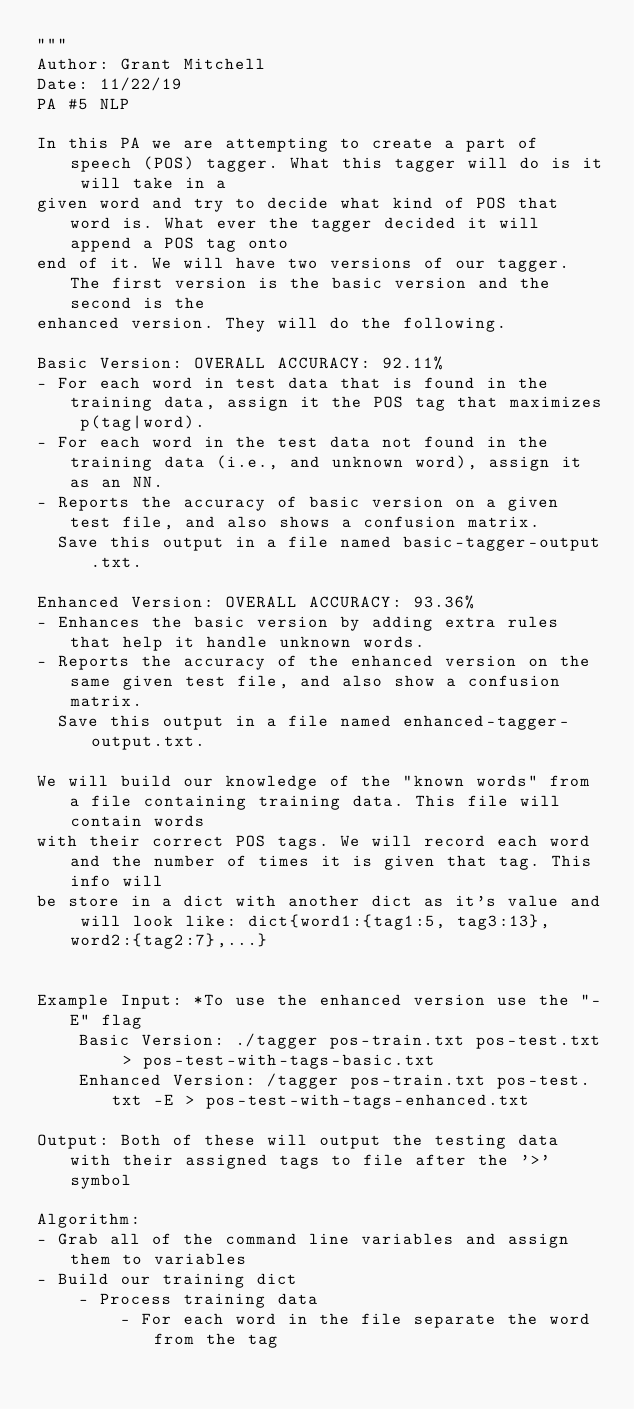Convert code to text. <code><loc_0><loc_0><loc_500><loc_500><_Python_>"""
Author: Grant Mitchell
Date: 11/22/19
PA #5 NLP

In this PA we are attempting to create a part of speech (POS) tagger. What this tagger will do is it will take in a
given word and try to decide what kind of POS that word is. What ever the tagger decided it will append a POS tag onto
end of it. We will have two versions of our tagger. The first version is the basic version and the second is the
enhanced version. They will do the following.

Basic Version: OVERALL ACCURACY: 92.11%
- For each word in test data that is found in the training data, assign it the POS tag that maximizes p(tag|word).
- For each word in the test data not found in the training data (i.e., and unknown word), assign it as an NN.
- Reports the accuracy of basic version on a given test file, and also shows a confusion matrix.
  Save this output in a file named basic-tagger-output.txt.

Enhanced Version: OVERALL ACCURACY: 93.36%
- Enhances the basic version by adding extra rules that help it handle unknown words.
- Reports the accuracy of the enhanced version on the same given test file, and also show a confusion matrix.
  Save this output in a file named enhanced-tagger-output.txt.

We will build our knowledge of the "known words" from a file containing training data. This file will contain words
with their correct POS tags. We will record each word and the number of times it is given that tag. This info will
be store in a dict with another dict as it's value and will look like: dict{word1:{tag1:5, tag3:13}, word2:{tag2:7},...}


Example Input: *To use the enhanced version use the "-E" flag
    Basic Version: ./tagger pos-train.txt pos-test.txt > pos-test-with-tags-basic.txt
    Enhanced Version: /tagger pos-train.txt pos-test.txt -E > pos-test-with-tags-enhanced.txt

Output: Both of these will output the testing data with their assigned tags to file after the '>' symbol

Algorithm:
- Grab all of the command line variables and assign them to variables
- Build our training dict
    - Process training data
        - For each word in the file separate the word from the tag</code> 